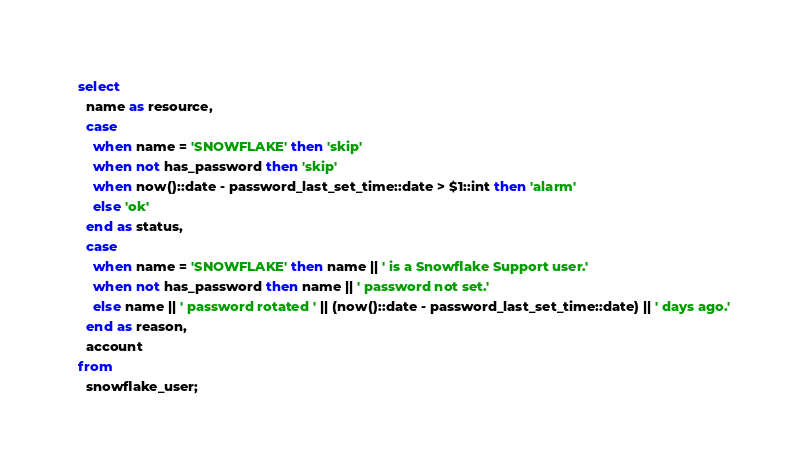<code> <loc_0><loc_0><loc_500><loc_500><_SQL_>select
  name as resource,
  case
    when name = 'SNOWFLAKE' then 'skip'
    when not has_password then 'skip'
    when now()::date - password_last_set_time::date > $1::int then 'alarm'
    else 'ok'
  end as status,
  case
    when name = 'SNOWFLAKE' then name || ' is a Snowflake Support user.'
    when not has_password then name || ' password not set.'
    else name || ' password rotated ' || (now()::date - password_last_set_time::date) || ' days ago.'
  end as reason,
  account
from
  snowflake_user;
</code> 